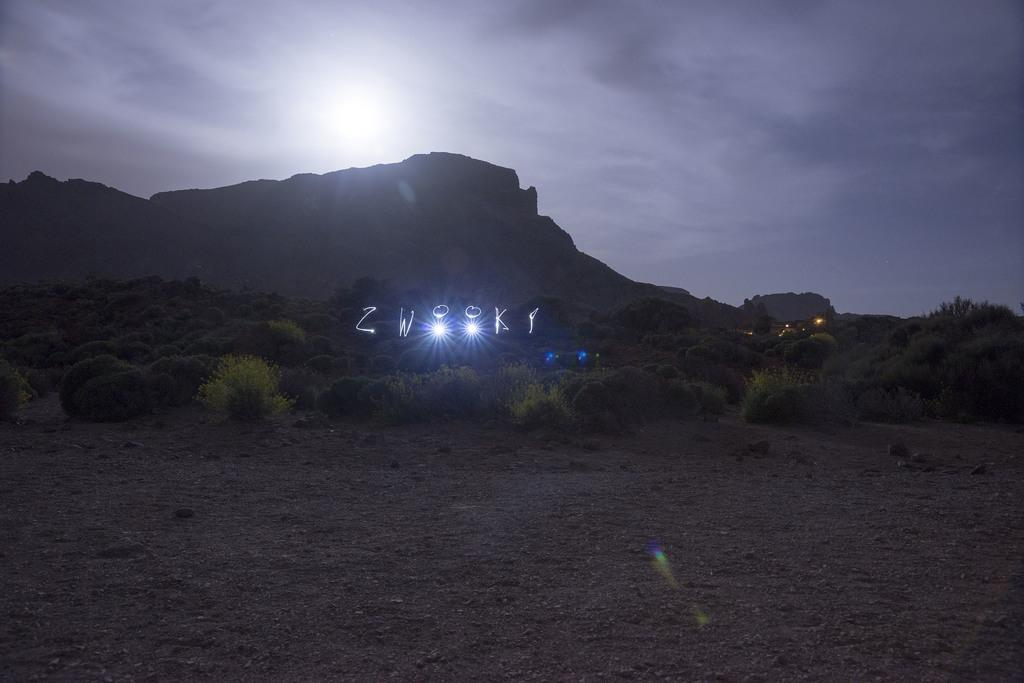What type of landscape can be seen in the image? There are hills in the image. What can be seen illuminating the landscape in the image? There are lights in the image. What type of vegetation is present in the image? There are shrubs and trees in the image. What celestial body is visible in the sky in the image? The moon is visible in the sky. What is visible at the bottom of the image? There is ground visible at the bottom of the image. What type of flowers can be seen growing on the waves in the image? There are no waves or flowers present in the image. 